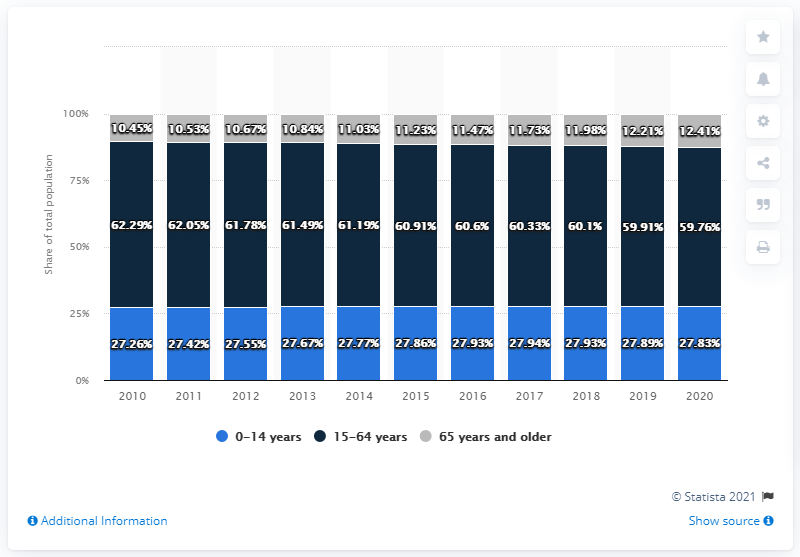Specify some key components in this picture. The difference between the shortest light blue bar and the tallest grey bar is 14.85. The highest and lowest value in 2017 were 48.6 respectively. 